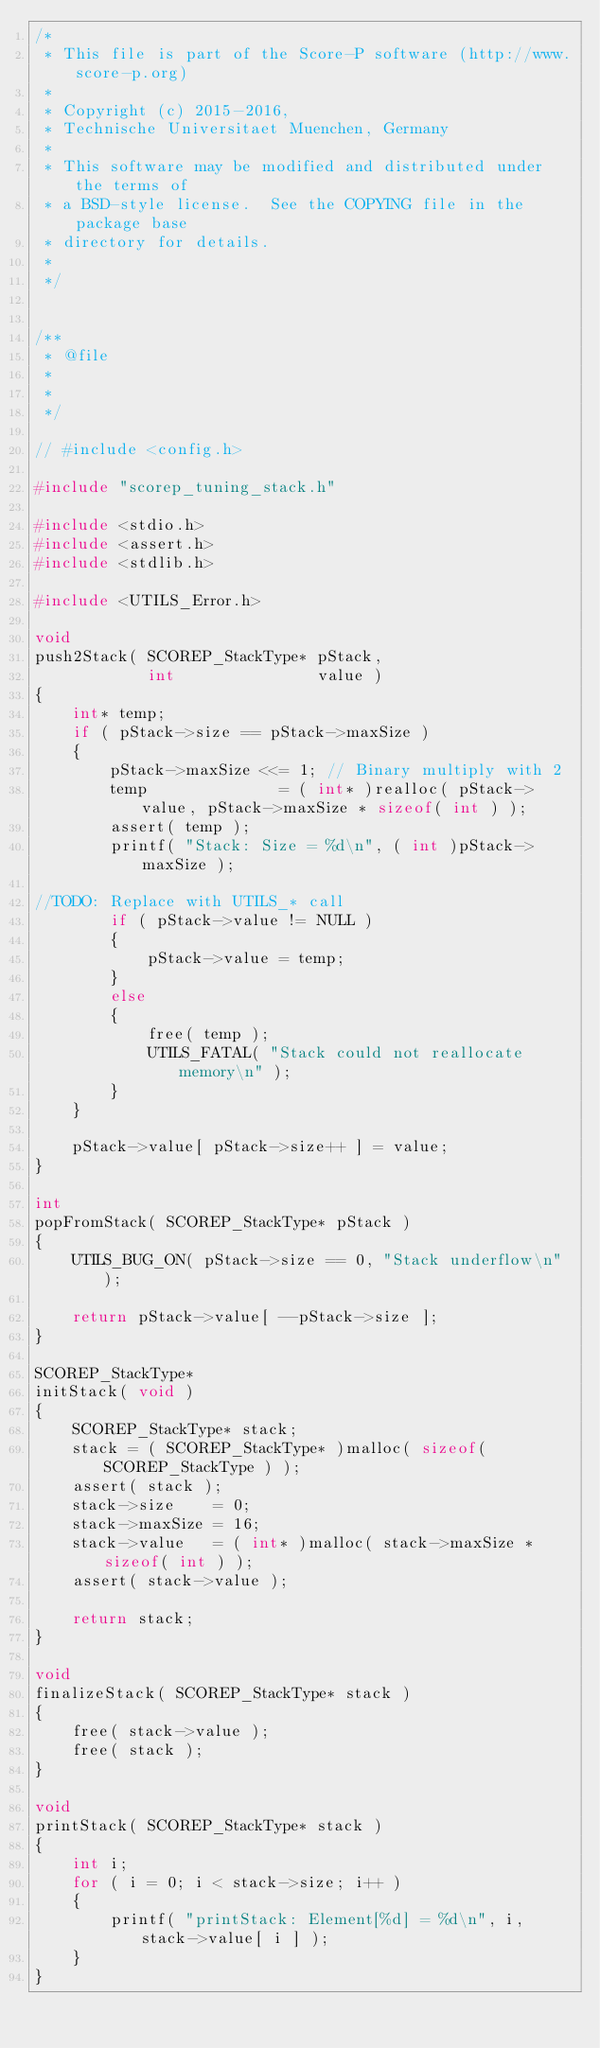<code> <loc_0><loc_0><loc_500><loc_500><_C_>/*
 * This file is part of the Score-P software (http://www.score-p.org)
 *
 * Copyright (c) 2015-2016,
 * Technische Universitaet Muenchen, Germany
 *
 * This software may be modified and distributed under the terms of
 * a BSD-style license.  See the COPYING file in the package base
 * directory for details.
 *
 */


/**
 * @file
 *
 *
 */

// #include <config.h>

#include "scorep_tuning_stack.h"

#include <stdio.h>
#include <assert.h>
#include <stdlib.h>

#include <UTILS_Error.h>

void
push2Stack( SCOREP_StackType* pStack,
            int               value )
{
    int* temp;
    if ( pStack->size == pStack->maxSize )
    {
        pStack->maxSize <<= 1; // Binary multiply with 2
        temp              = ( int* )realloc( pStack->value, pStack->maxSize * sizeof( int ) );
        assert( temp );
        printf( "Stack: Size = %d\n", ( int )pStack->maxSize );

//TODO: Replace with UTILS_* call
        if ( pStack->value != NULL )
        {
            pStack->value = temp;
        }
        else
        {
            free( temp );
            UTILS_FATAL( "Stack could not reallocate memory\n" );
        }
    }

    pStack->value[ pStack->size++ ] = value;
}

int
popFromStack( SCOREP_StackType* pStack )
{
    UTILS_BUG_ON( pStack->size == 0, "Stack underflow\n" );

    return pStack->value[ --pStack->size ];
}

SCOREP_StackType*
initStack( void )
{
    SCOREP_StackType* stack;
    stack = ( SCOREP_StackType* )malloc( sizeof( SCOREP_StackType ) );
    assert( stack );
    stack->size    = 0;
    stack->maxSize = 16;
    stack->value   = ( int* )malloc( stack->maxSize * sizeof( int ) );
    assert( stack->value );

    return stack;
}

void
finalizeStack( SCOREP_StackType* stack )
{
    free( stack->value );
    free( stack );
}

void
printStack( SCOREP_StackType* stack )
{
    int i;
    for ( i = 0; i < stack->size; i++ )
    {
        printf( "printStack: Element[%d] = %d\n", i, stack->value[ i ] );
    }
}
</code> 